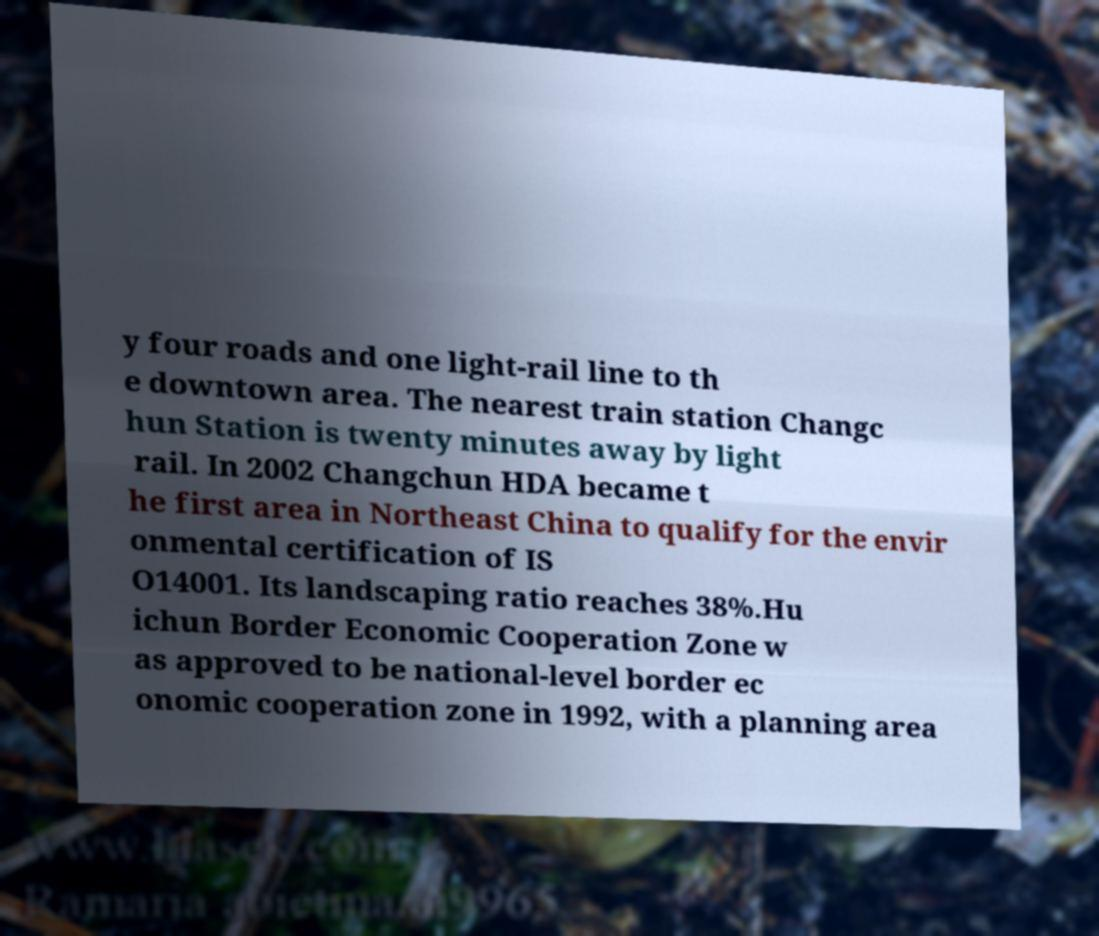Could you assist in decoding the text presented in this image and type it out clearly? y four roads and one light-rail line to th e downtown area. The nearest train station Changc hun Station is twenty minutes away by light rail. In 2002 Changchun HDA became t he first area in Northeast China to qualify for the envir onmental certification of IS O14001. Its landscaping ratio reaches 38%.Hu ichun Border Economic Cooperation Zone w as approved to be national-level border ec onomic cooperation zone in 1992, with a planning area 